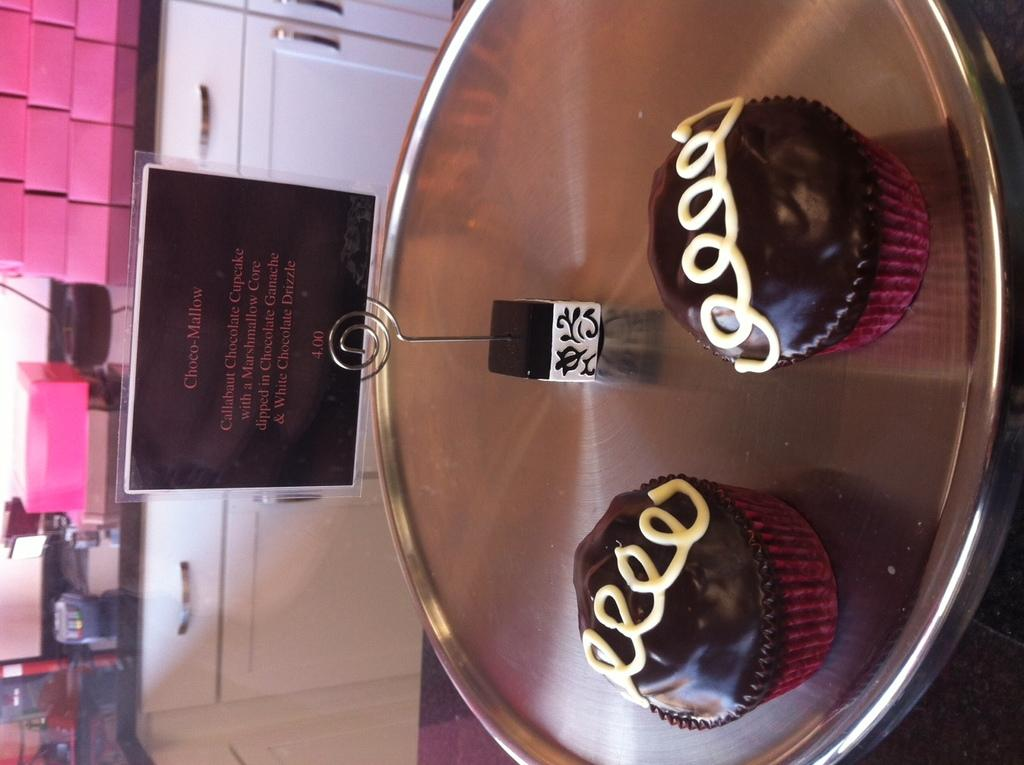Provide a one-sentence caption for the provided image. Two cupcakes called Choco-Mallow on a silver tray. 